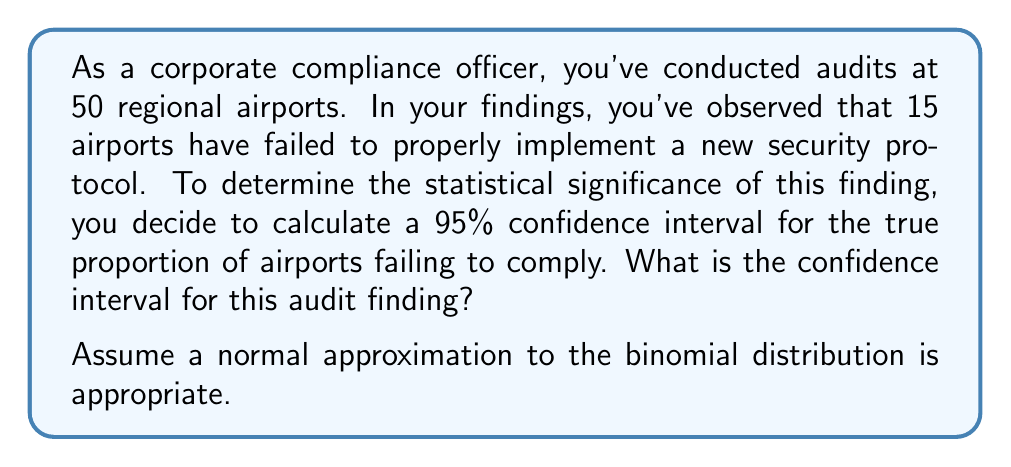Can you solve this math problem? To calculate the confidence interval for a proportion, we'll use the formula:

$$ \hat{p} \pm z_{\alpha/2} \sqrt{\frac{\hat{p}(1-\hat{p})}{n}} $$

Where:
- $\hat{p}$ is the sample proportion
- $z_{\alpha/2}$ is the critical value for the desired confidence level
- $n$ is the sample size

Step 1: Calculate the sample proportion $\hat{p}$
$$ \hat{p} = \frac{\text{number of airports failing}}{\text{total airports audited}} = \frac{15}{50} = 0.3 $$

Step 2: Determine the critical value $z_{\alpha/2}$
For a 95% confidence interval, $\alpha = 0.05$ and $z_{\alpha/2} = 1.96$

Step 3: Calculate the standard error
$$ SE = \sqrt{\frac{\hat{p}(1-\hat{p})}{n}} = \sqrt{\frac{0.3(1-0.3)}{50}} = 0.0648 $$

Step 4: Calculate the margin of error
$$ ME = z_{\alpha/2} * SE = 1.96 * 0.0648 = 0.1270 $$

Step 5: Calculate the confidence interval
Lower bound: $0.3 - 0.1270 = 0.1730$
Upper bound: $0.3 + 0.1270 = 0.4270$

Therefore, the 95% confidence interval is (0.1730, 0.4270) or (17.30%, 42.70%).
Answer: The 95% confidence interval for the true proportion of airports failing to comply with the new security protocol is (0.1730, 0.4270) or (17.30%, 42.70%). 